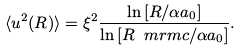Convert formula to latex. <formula><loc_0><loc_0><loc_500><loc_500>\langle u ^ { 2 } ( R ) \rangle = \xi ^ { 2 } \frac { \ln \left [ R / \alpha a _ { 0 } \right ] } { \ln \left [ R _ { \ } m r m { c } / \alpha a _ { 0 } \right ] } .</formula> 